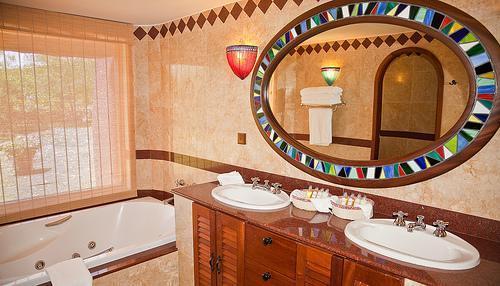How many sinks are there?
Give a very brief answer. 2. 